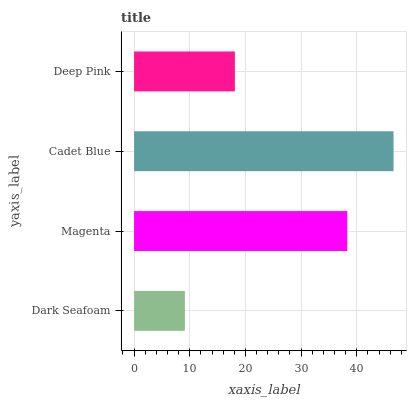Is Dark Seafoam the minimum?
Answer yes or no. Yes. Is Cadet Blue the maximum?
Answer yes or no. Yes. Is Magenta the minimum?
Answer yes or no. No. Is Magenta the maximum?
Answer yes or no. No. Is Magenta greater than Dark Seafoam?
Answer yes or no. Yes. Is Dark Seafoam less than Magenta?
Answer yes or no. Yes. Is Dark Seafoam greater than Magenta?
Answer yes or no. No. Is Magenta less than Dark Seafoam?
Answer yes or no. No. Is Magenta the high median?
Answer yes or no. Yes. Is Deep Pink the low median?
Answer yes or no. Yes. Is Deep Pink the high median?
Answer yes or no. No. Is Dark Seafoam the low median?
Answer yes or no. No. 